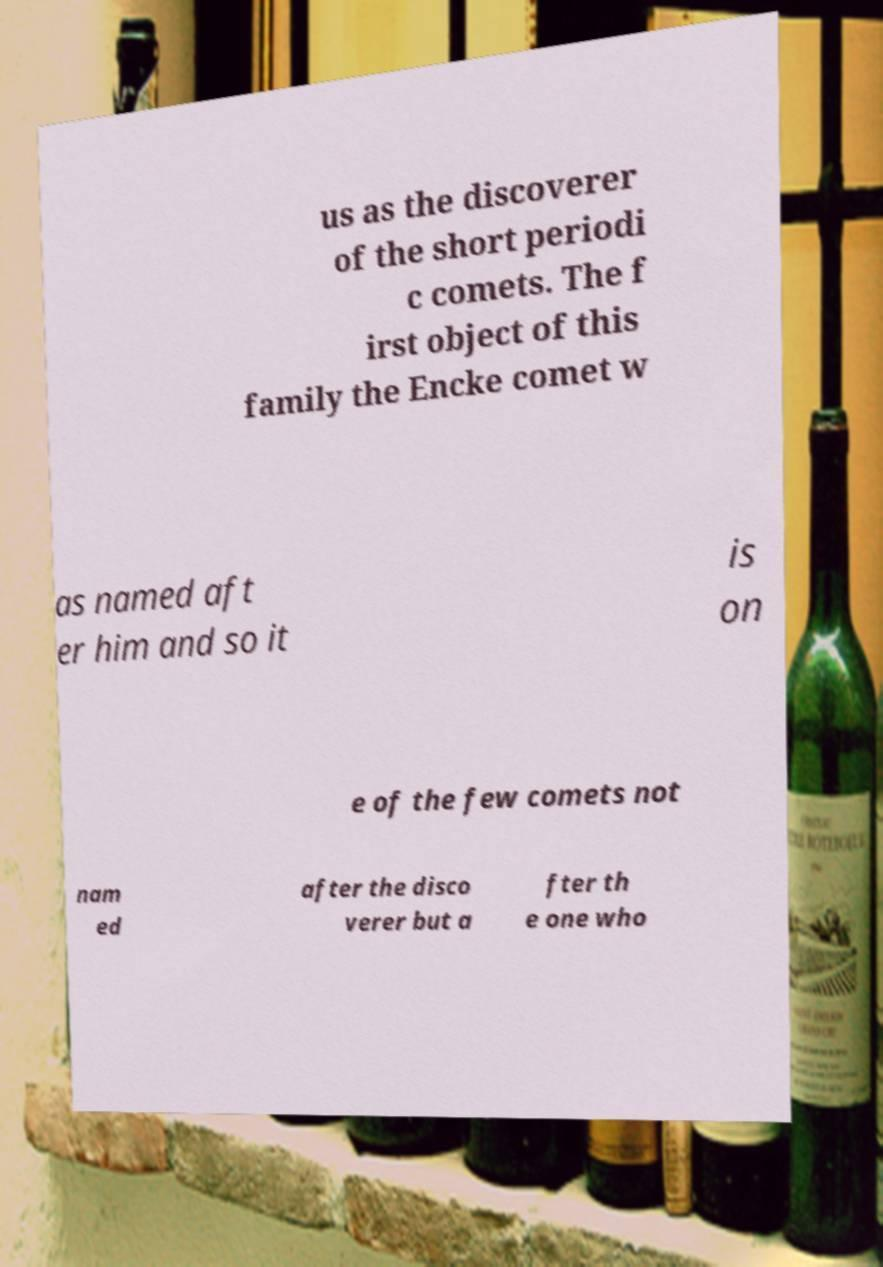Can you accurately transcribe the text from the provided image for me? us as the discoverer of the short periodi c comets. The f irst object of this family the Encke comet w as named aft er him and so it is on e of the few comets not nam ed after the disco verer but a fter th e one who 